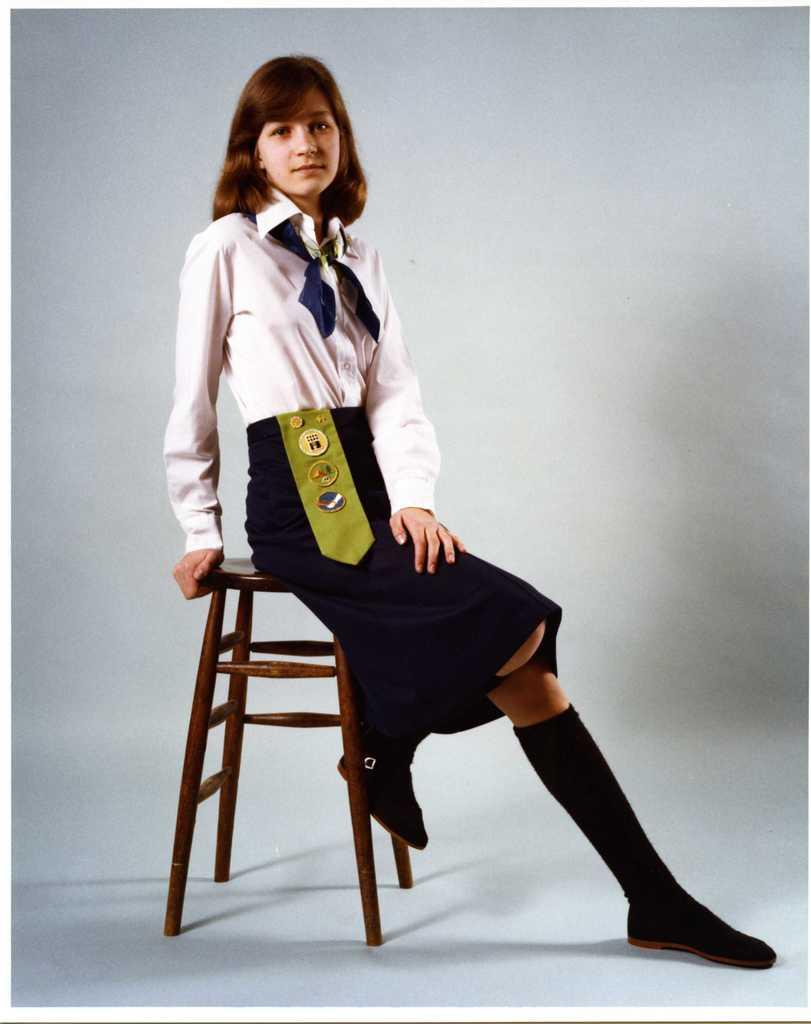Who is the main subject in the image? There is a woman in the image. What is the woman doing in the image? The woman is sitting on a chair. What can be seen below the woman in the image? The floor is visible in the image. What color is the background in the image? The background of the image is white. What type of toe is the woman using to answer the question in the image? There is no question being asked or answered in the image, and the woman's toes are not involved in any action. 